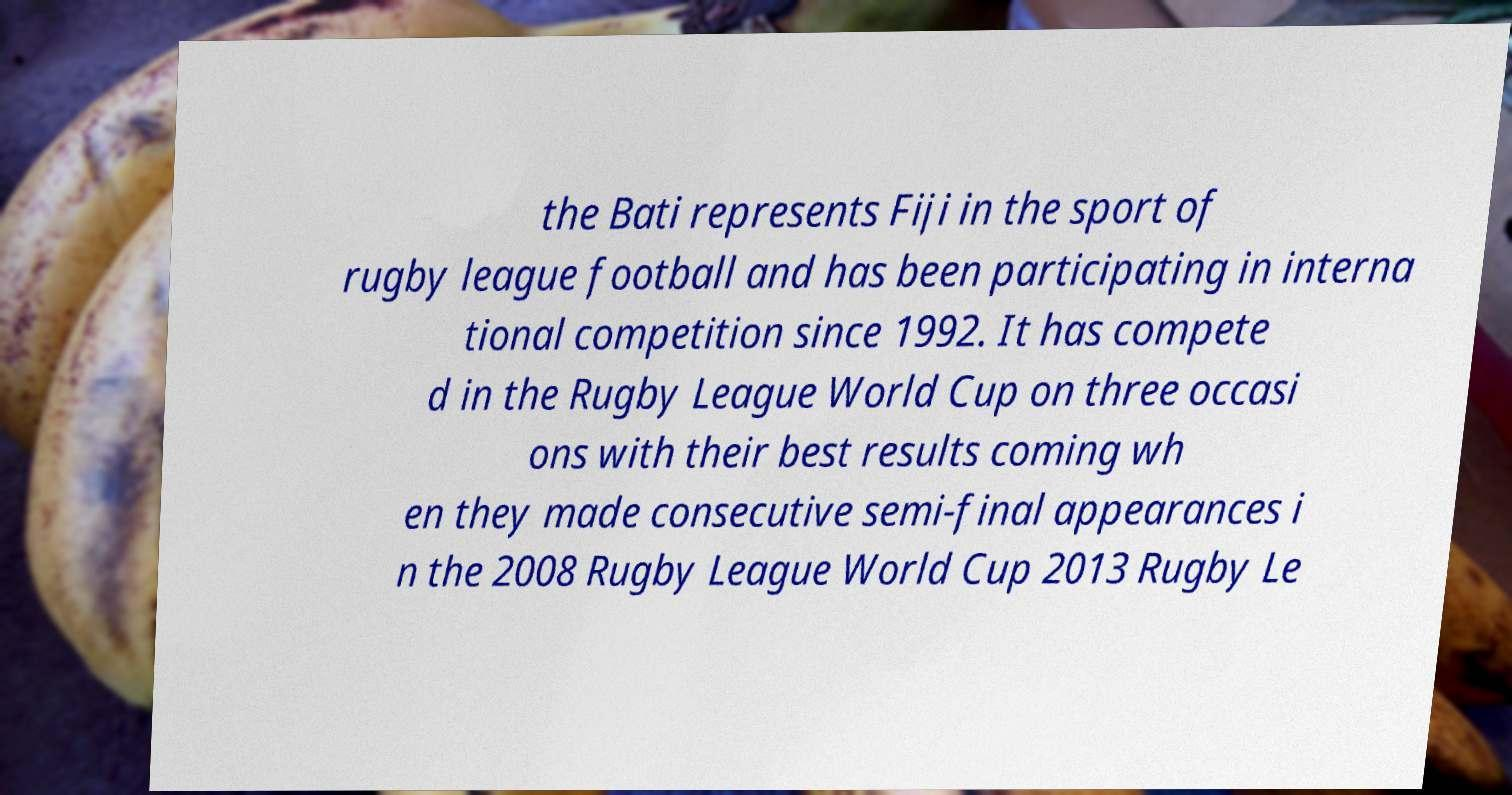Could you assist in decoding the text presented in this image and type it out clearly? the Bati represents Fiji in the sport of rugby league football and has been participating in interna tional competition since 1992. It has compete d in the Rugby League World Cup on three occasi ons with their best results coming wh en they made consecutive semi-final appearances i n the 2008 Rugby League World Cup 2013 Rugby Le 